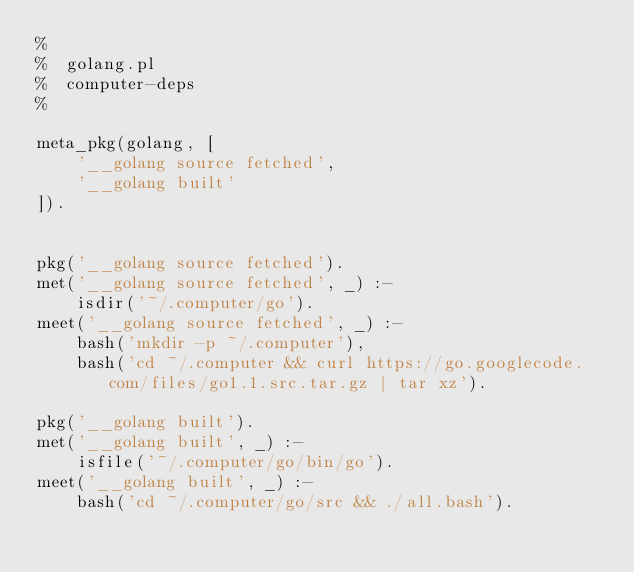Convert code to text. <code><loc_0><loc_0><loc_500><loc_500><_Perl_>%
%  golang.pl
%  computer-deps
%

meta_pkg(golang, [
    '__golang source fetched',
    '__golang built'
]).


pkg('__golang source fetched').
met('__golang source fetched', _) :-
    isdir('~/.computer/go').
meet('__golang source fetched', _) :-
    bash('mkdir -p ~/.computer'),
    bash('cd ~/.computer && curl https://go.googlecode.com/files/go1.1.src.tar.gz | tar xz').

pkg('__golang built').
met('__golang built', _) :-
    isfile('~/.computer/go/bin/go').
meet('__golang built', _) :-
    bash('cd ~/.computer/go/src && ./all.bash').
</code> 